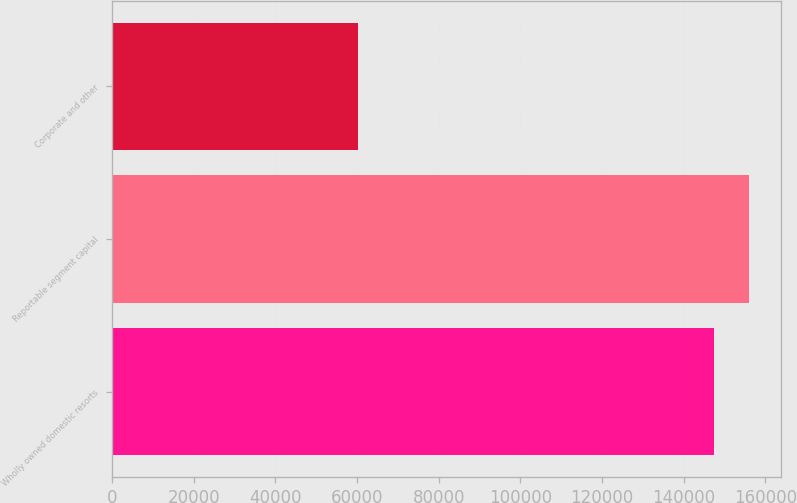<chart> <loc_0><loc_0><loc_500><loc_500><bar_chart><fcel>Wholly owned domestic resorts<fcel>Reportable segment capital<fcel>Corporate and other<nl><fcel>147317<fcel>156031<fcel>60174<nl></chart> 